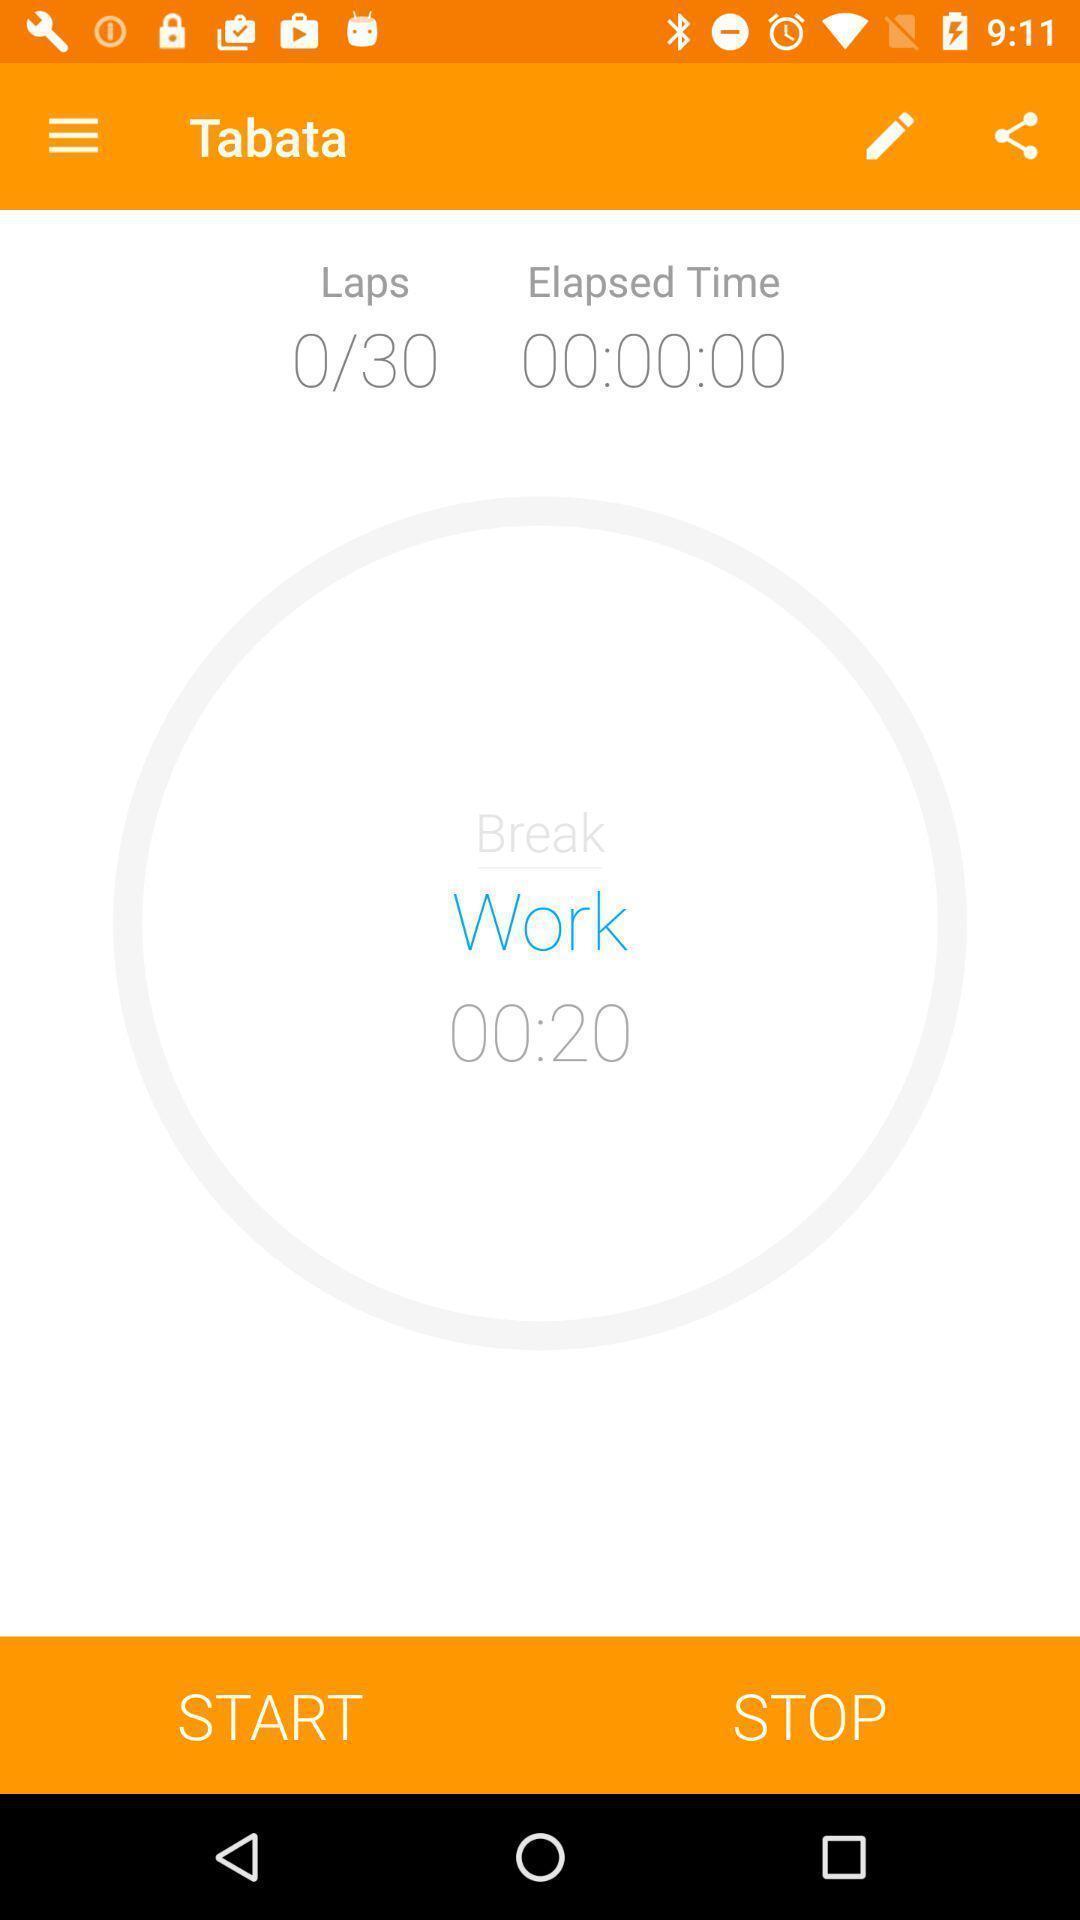What is the overall content of this screenshot? Screen shows an exercise timer. 